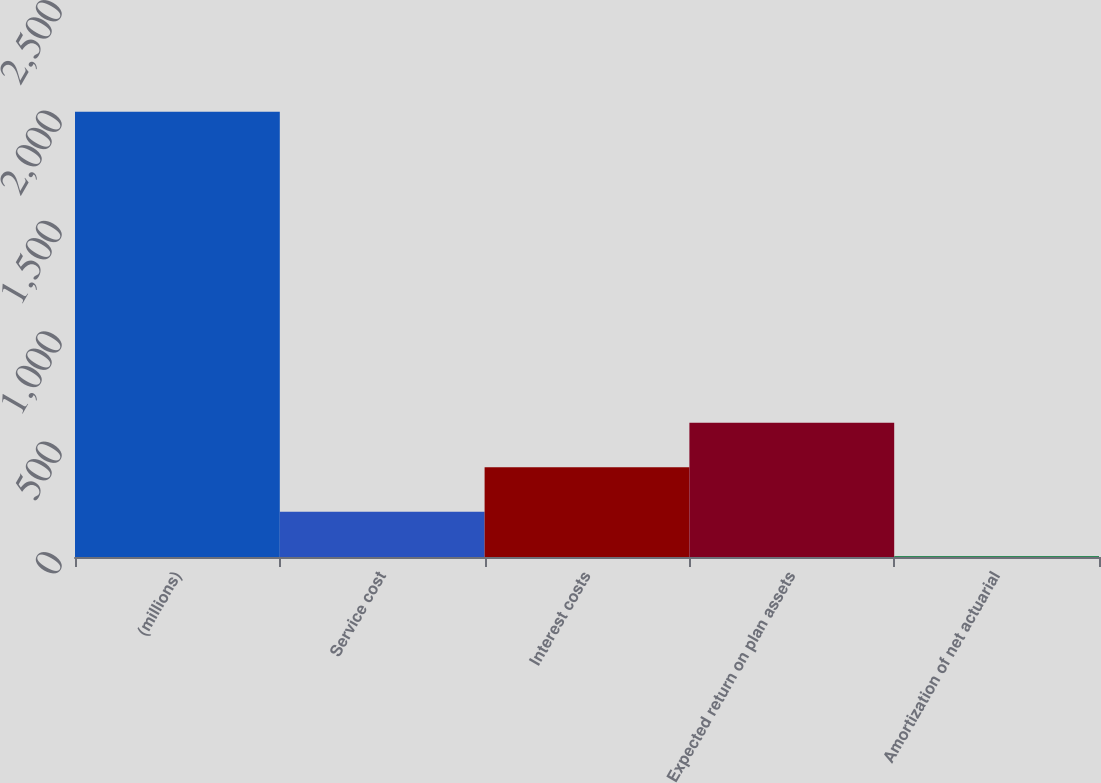Convert chart to OTSL. <chart><loc_0><loc_0><loc_500><loc_500><bar_chart><fcel>(millions)<fcel>Service cost<fcel>Interest costs<fcel>Expected return on plan assets<fcel>Amortization of net actuarial<nl><fcel>2016<fcel>205.29<fcel>406.48<fcel>607.67<fcel>4.1<nl></chart> 